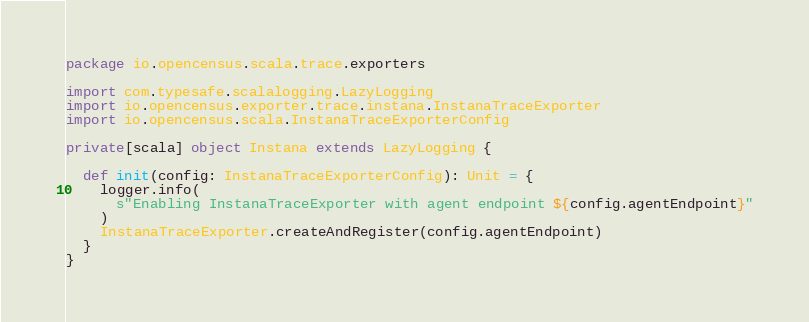<code> <loc_0><loc_0><loc_500><loc_500><_Scala_>package io.opencensus.scala.trace.exporters

import com.typesafe.scalalogging.LazyLogging
import io.opencensus.exporter.trace.instana.InstanaTraceExporter
import io.opencensus.scala.InstanaTraceExporterConfig

private[scala] object Instana extends LazyLogging {

  def init(config: InstanaTraceExporterConfig): Unit = {
    logger.info(
      s"Enabling InstanaTraceExporter with agent endpoint ${config.agentEndpoint}"
    )
    InstanaTraceExporter.createAndRegister(config.agentEndpoint)
  }
}
</code> 